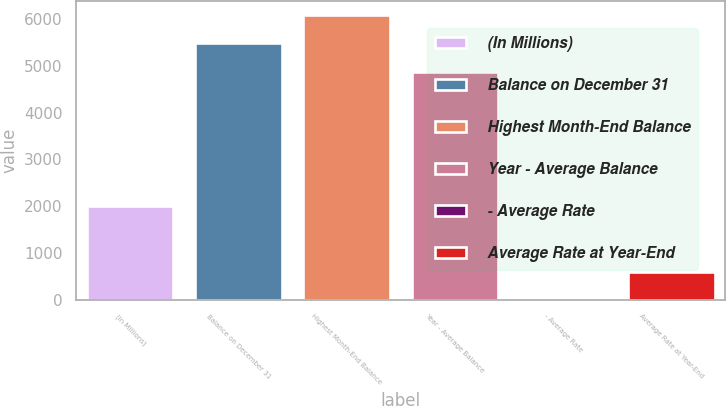Convert chart. <chart><loc_0><loc_0><loc_500><loc_500><bar_chart><fcel>(In Millions)<fcel>Balance on December 31<fcel>Highest Month-End Balance<fcel>Year - Average Balance<fcel>- Average Rate<fcel>Average Rate at Year-End<nl><fcel>2016<fcel>5475.82<fcel>6079.54<fcel>4872.1<fcel>0.37<fcel>604.09<nl></chart> 